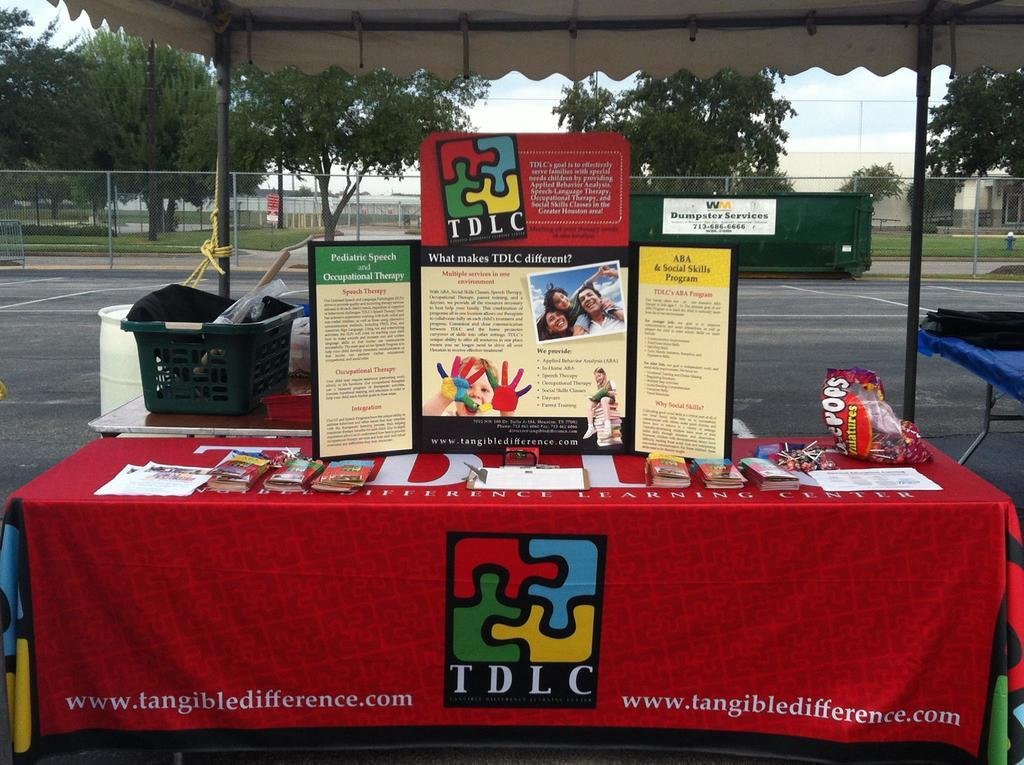<image>
Create a compact narrative representing the image presented. A table is set up in a parking lot for information about TDLC program. 